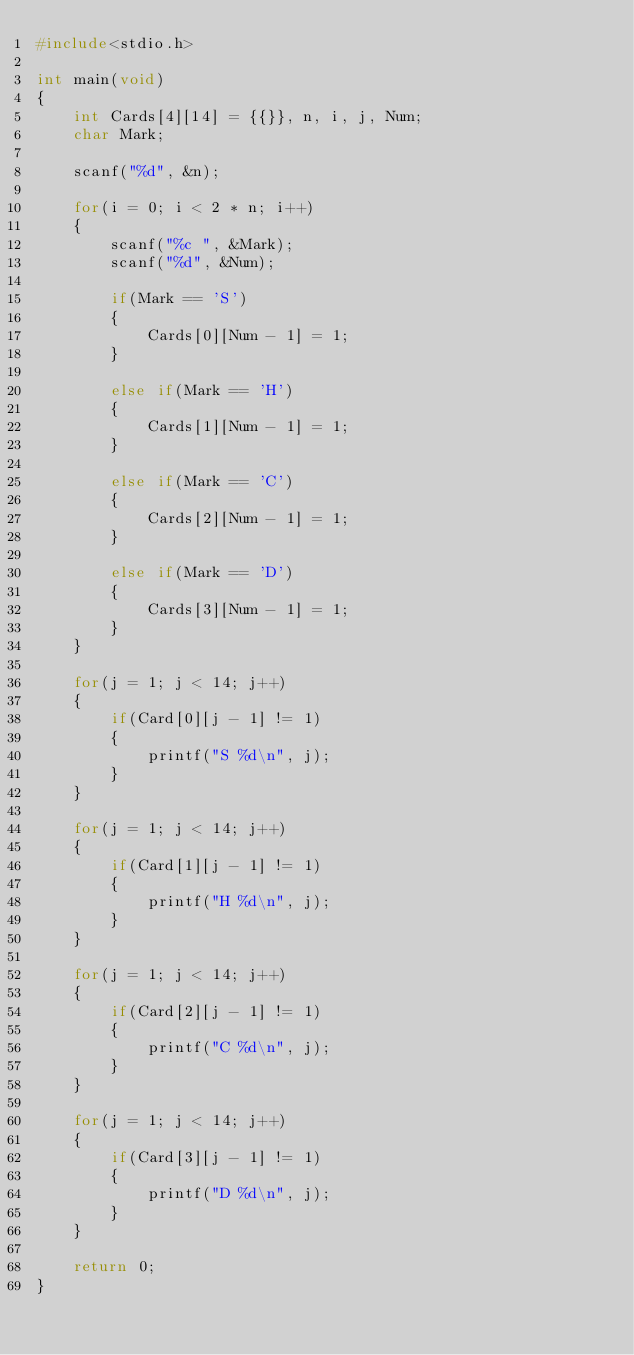<code> <loc_0><loc_0><loc_500><loc_500><_C_>#include<stdio.h>

int main(void)
{
    int Cards[4][14] = {{}}, n, i, j, Num;
    char Mark; 

    scanf("%d", &n);

    for(i = 0; i < 2 * n; i++)
    {
        scanf("%c ", &Mark);
        scanf("%d", &Num);
        
        if(Mark == 'S')
        {
            Cards[0][Num - 1] = 1;
        }

        else if(Mark == 'H')
        {
            Cards[1][Num - 1] = 1;
        }

        else if(Mark == 'C')
        {
            Cards[2][Num - 1] = 1;
        }

        else if(Mark == 'D')
        {
            Cards[3][Num - 1] = 1;
        }
    }

    for(j = 1; j < 14; j++)
    {
        if(Card[0][j - 1] != 1)
        {
            printf("S %d\n", j);
        }
    }

    for(j = 1; j < 14; j++)
    {
        if(Card[1][j - 1] != 1)
        {
            printf("H %d\n", j);
        }
    }

    for(j = 1; j < 14; j++)
    {
        if(Card[2][j - 1] != 1)
        {
            printf("C %d\n", j);
        }
    }

    for(j = 1; j < 14; j++)
    {
        if(Card[3][j - 1] != 1)
        {
            printf("D %d\n", j);
        }
    }
    
    return 0;
}
</code> 